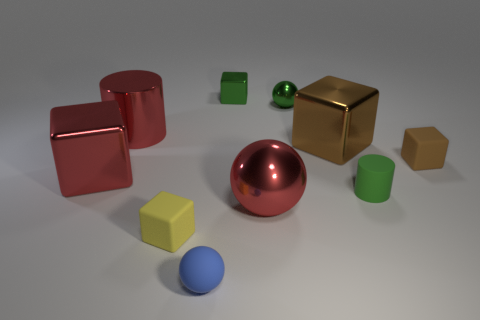Subtract all green cubes. How many cubes are left? 4 Subtract all yellow blocks. How many blocks are left? 4 Subtract all blue cylinders. How many brown blocks are left? 2 Subtract 1 balls. How many balls are left? 2 Subtract all purple balls. Subtract all purple cylinders. How many balls are left? 3 Subtract all green metal objects. Subtract all large red metal cubes. How many objects are left? 7 Add 1 rubber things. How many rubber things are left? 5 Add 5 gray blocks. How many gray blocks exist? 5 Subtract 0 blue cylinders. How many objects are left? 10 Subtract all cylinders. How many objects are left? 8 